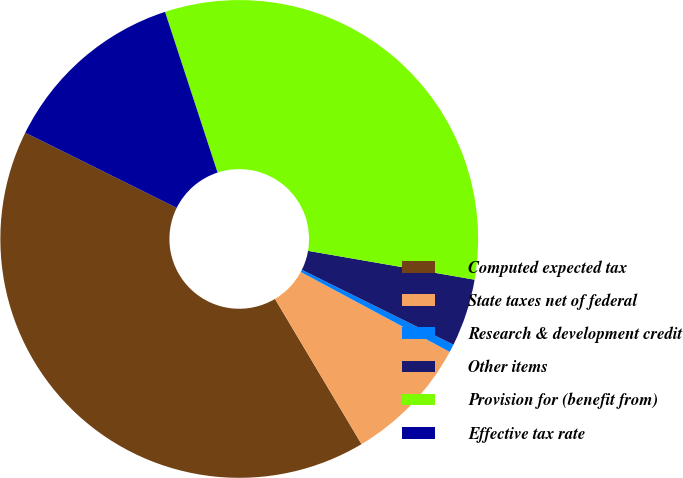Convert chart. <chart><loc_0><loc_0><loc_500><loc_500><pie_chart><fcel>Computed expected tax<fcel>State taxes net of federal<fcel>Research & development credit<fcel>Other items<fcel>Provision for (benefit from)<fcel>Effective tax rate<nl><fcel>40.89%<fcel>8.61%<fcel>0.54%<fcel>4.57%<fcel>32.76%<fcel>12.64%<nl></chart> 